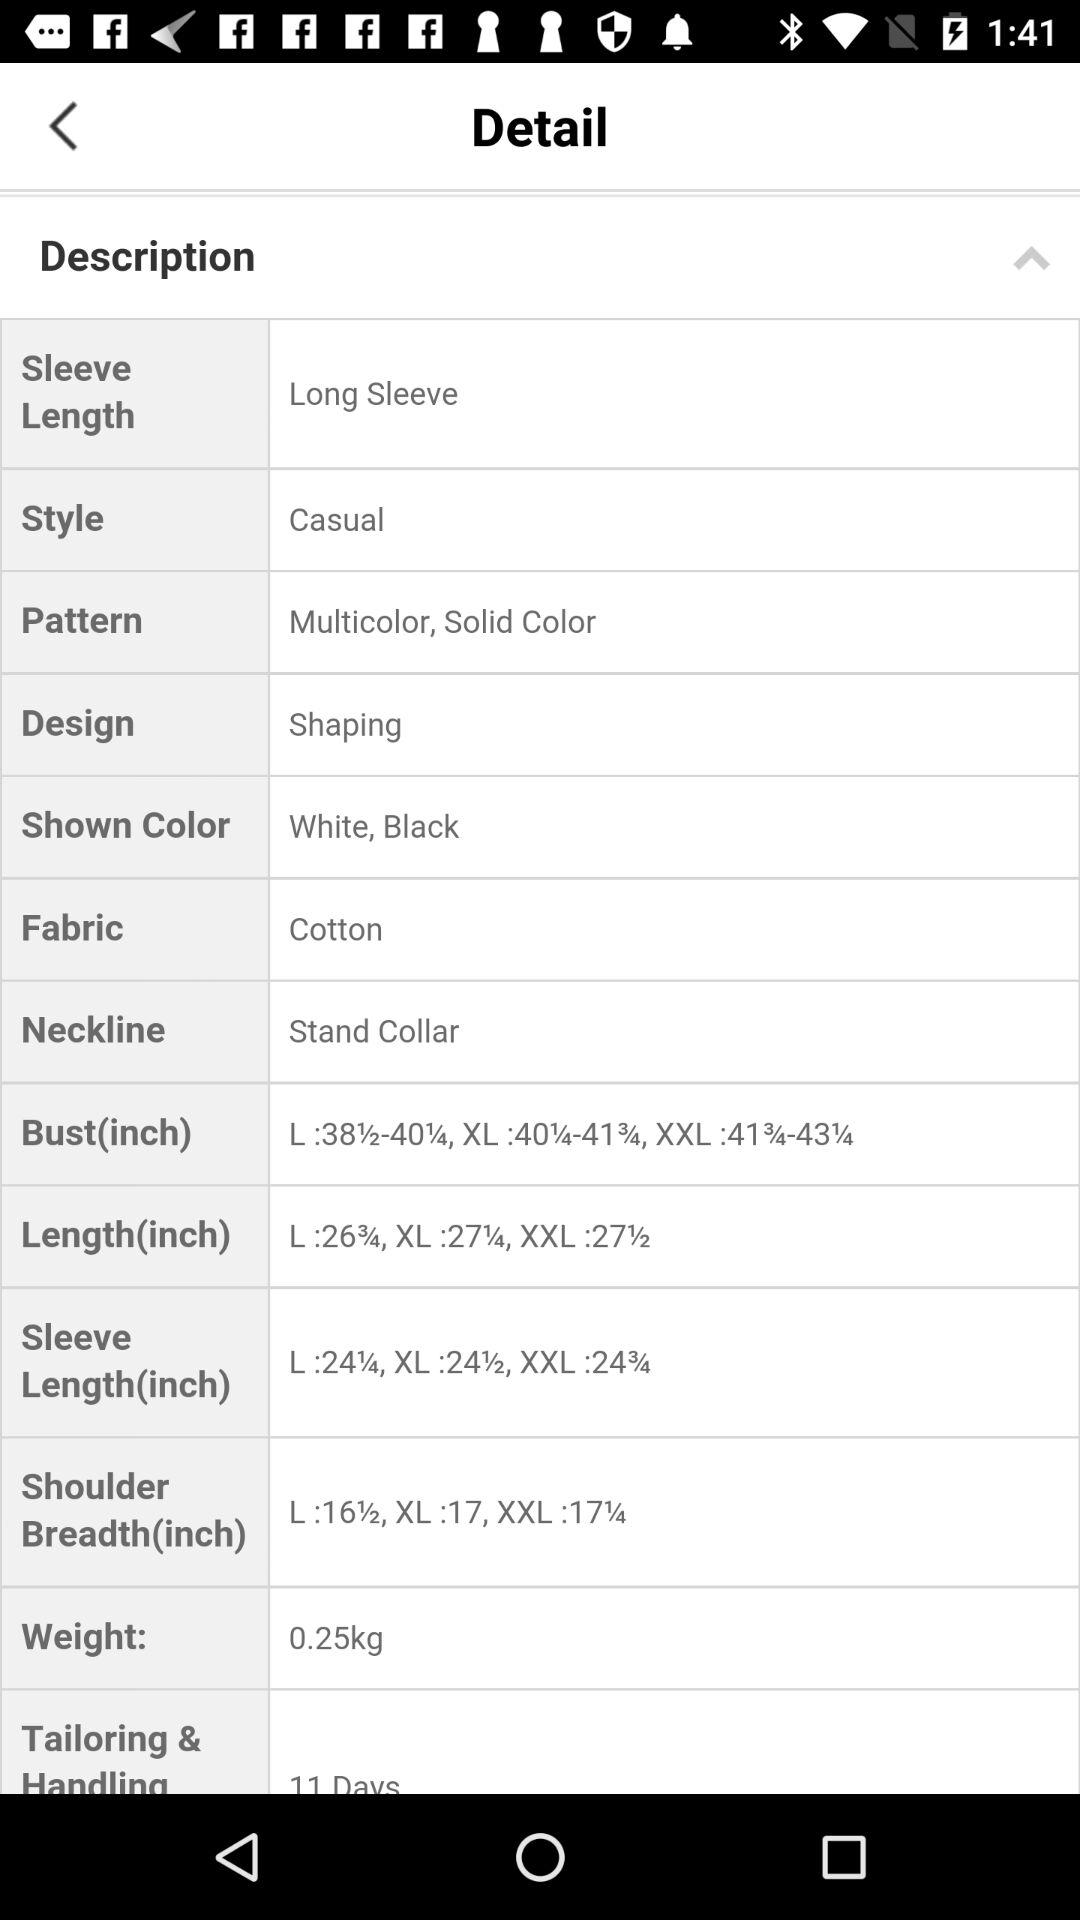What is the weight? The weight is 0.25kg. 